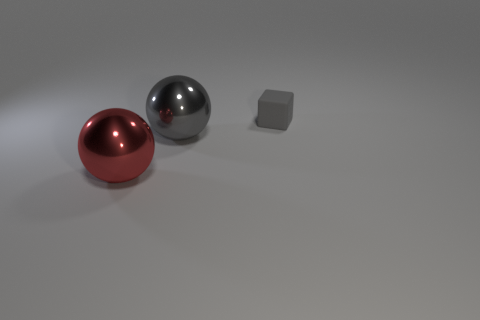How many metal things are large cyan spheres or big red objects?
Provide a succinct answer. 1. Is there anything else that is the same size as the matte thing?
Offer a very short reply. No. There is a shiny thing in front of the gray thing in front of the gray block; what shape is it?
Ensure brevity in your answer.  Sphere. Is the material of the gray object in front of the gray rubber block the same as the tiny gray block that is to the right of the big red thing?
Ensure brevity in your answer.  No. What number of big balls are right of the large object to the left of the large gray sphere?
Your answer should be compact. 1. Does the metallic thing that is behind the red shiny object have the same shape as the large red shiny thing that is to the left of the large gray sphere?
Provide a succinct answer. Yes. What size is the thing that is both behind the red metal sphere and on the left side of the tiny block?
Ensure brevity in your answer.  Large. There is another thing that is the same shape as the red object; what is its color?
Your response must be concise. Gray. What is the color of the large metallic sphere on the right side of the large shiny thing that is in front of the gray metal sphere?
Offer a very short reply. Gray. What shape is the small gray object?
Keep it short and to the point. Cube. 